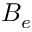<formula> <loc_0><loc_0><loc_500><loc_500>B _ { e }</formula> 